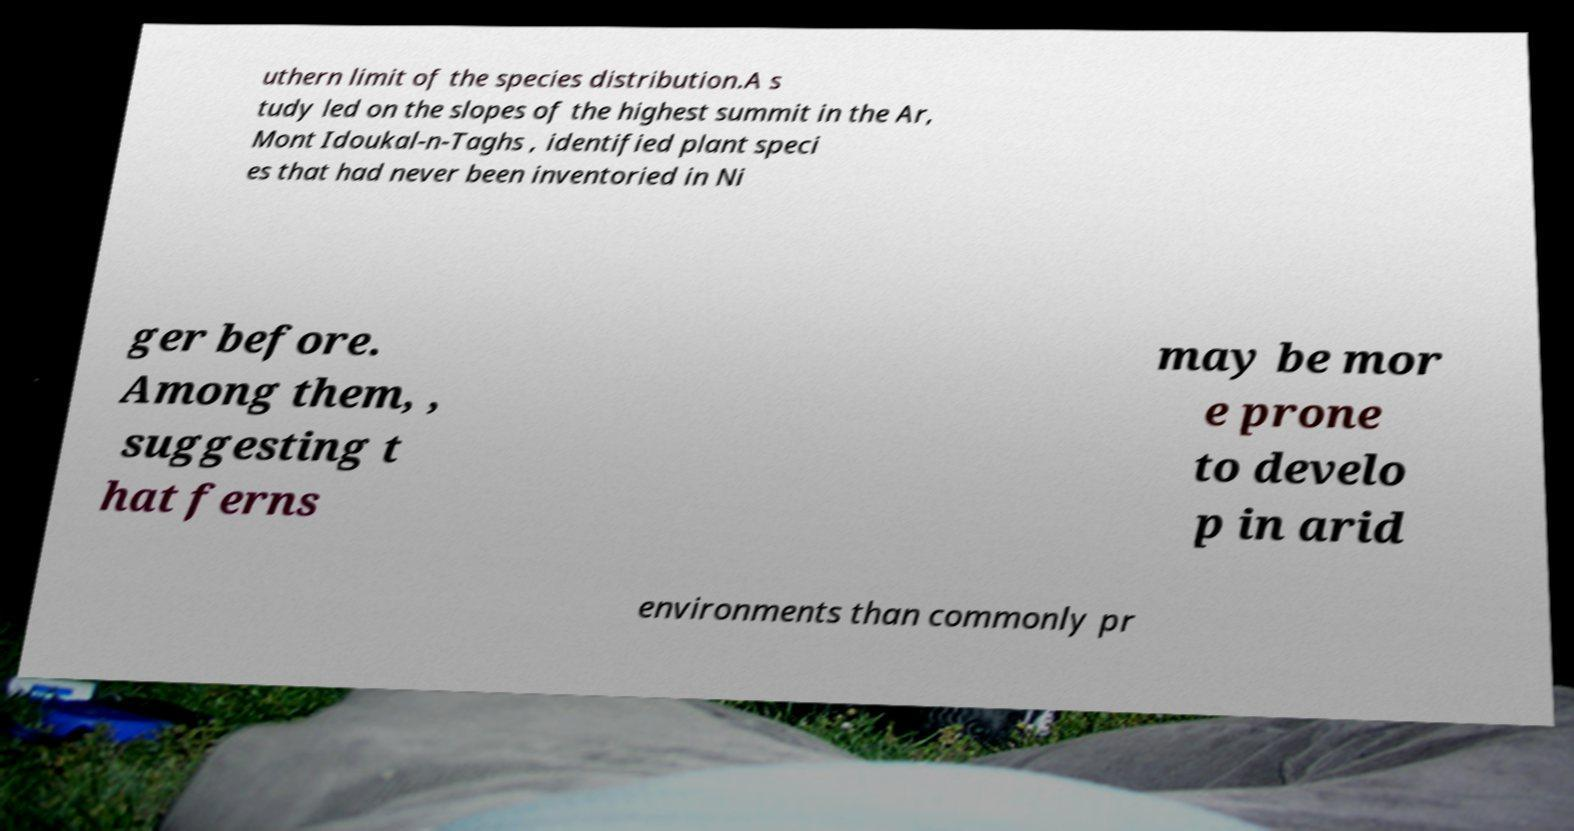I need the written content from this picture converted into text. Can you do that? uthern limit of the species distribution.A s tudy led on the slopes of the highest summit in the Ar, Mont Idoukal-n-Taghs , identified plant speci es that had never been inventoried in Ni ger before. Among them, , suggesting t hat ferns may be mor e prone to develo p in arid environments than commonly pr 